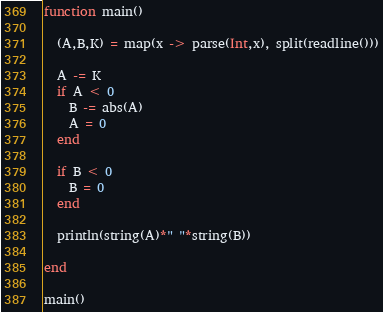<code> <loc_0><loc_0><loc_500><loc_500><_Julia_>function main()
  
  (A,B,K) = map(x -> parse(Int,x), split(readline()))
  
  A -= K
  if A < 0
    B -= abs(A)
    A = 0
  end
  
  if B < 0
    B = 0
  end
  
  println(string(A)*" "*string(B))
  
end

main()</code> 